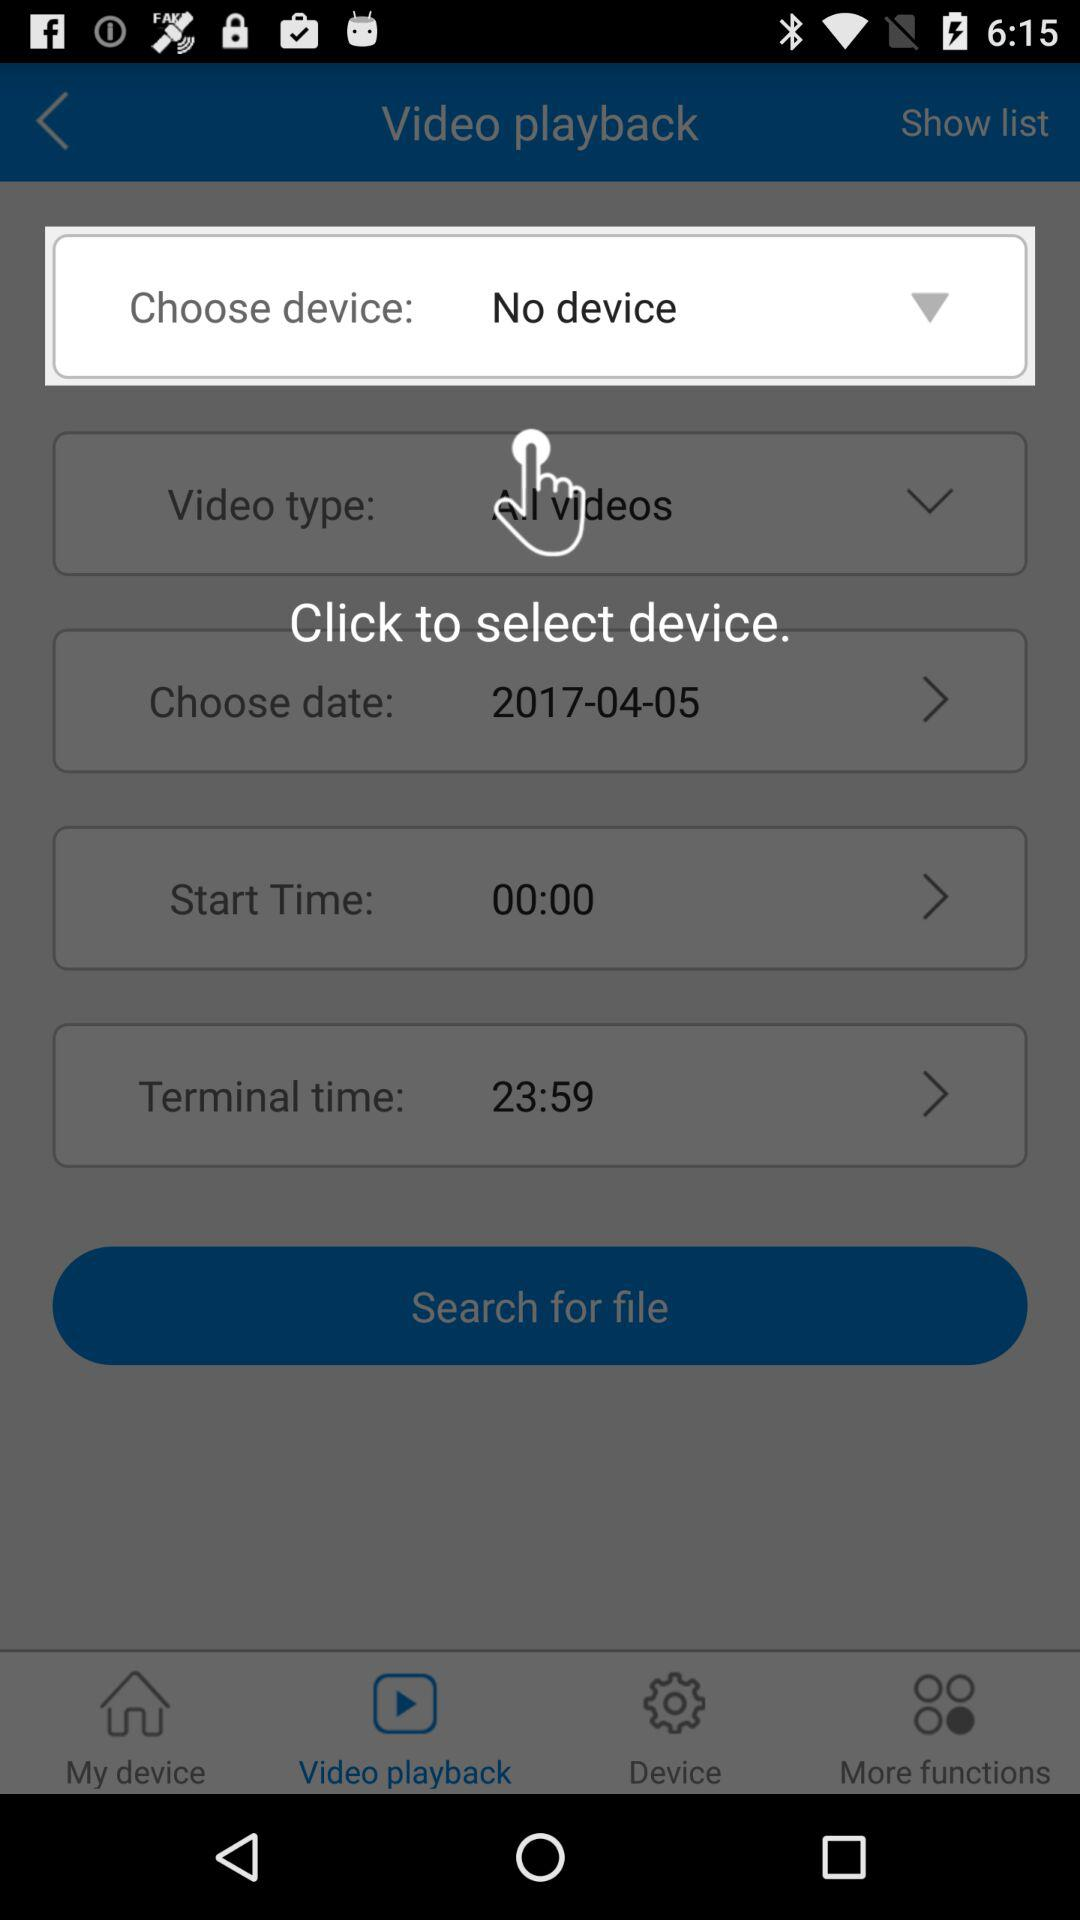Is there any device selected? There is no device selected. 